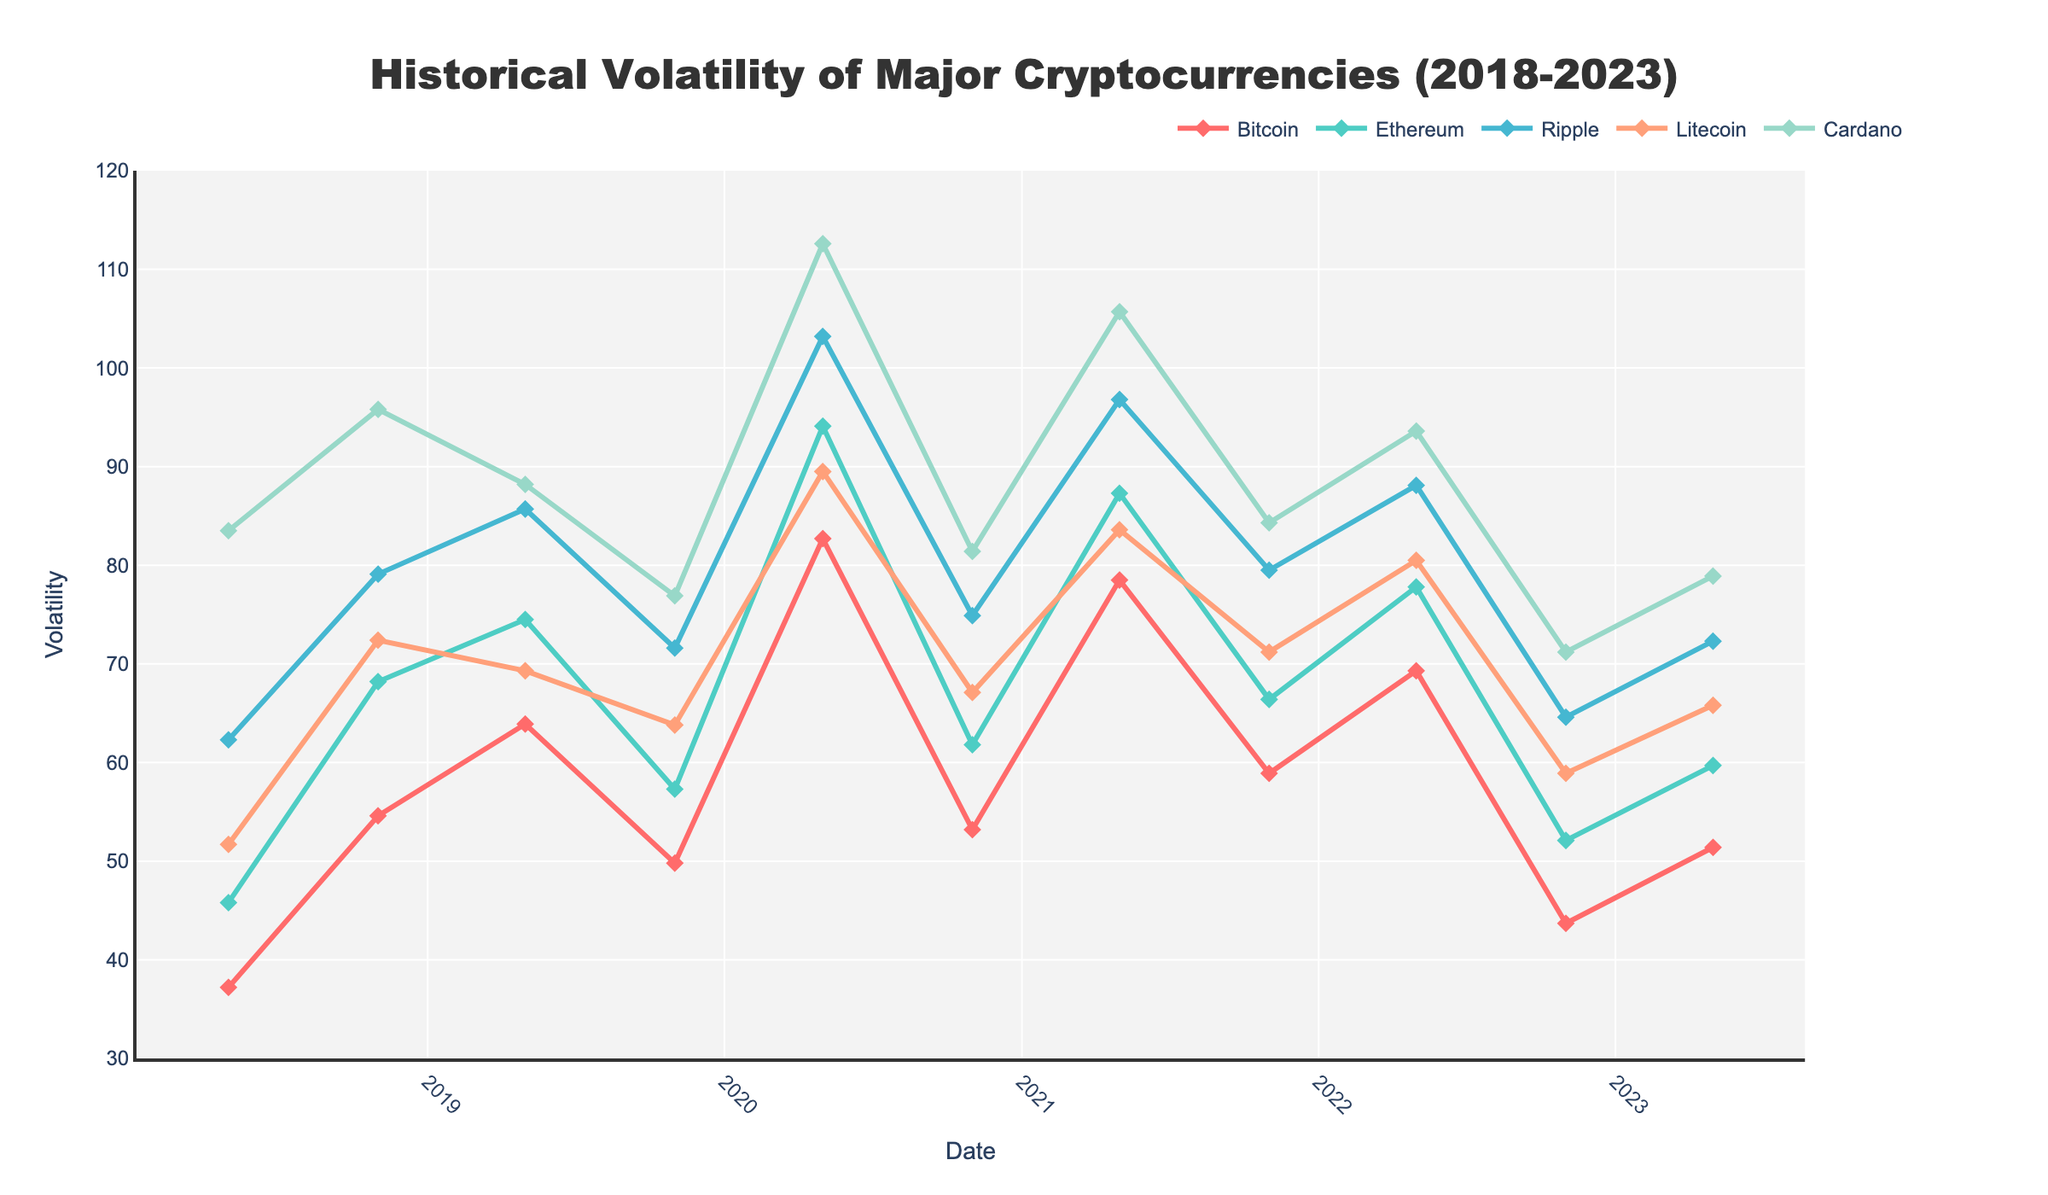Which cryptocurrency had the highest volatility in May 2020? Looking at the chart, find the highest point for May 2020. Cardano has the highest volatility among the cryptocurrencies listed.
Answer: Cardano How did Bitcoin's volatility change from November 2020 to May 2021? Locate Bitcoin's volatility values for November 2020 and May 2021. Bitcoin's volatility increased from 53.2 to 78.5.
Answer: It increased Which two cryptocurrencies had similar volatility in November 2022? Compare the volatility values of all cryptocurrencies for November 2022. Ripple and Litecoin had similar volatility values of 64.6 and 58.9, respectively.
Answer: Ripple and Litecoin What was the overall trend in Ethereum's volatility from 2018 to 2023? Observe Ethereum's volatility line from the start to the end of the period. Ethereum's volatility shows both increases and decreases but generally decreased over the period.
Answer: General decrease Between May 2021 and November 2021, which cryptocurrency experienced the largest decrease in volatility? Compare the drop in volatility for each cryptocurrency between these two dates. Bitcoin had the largest decrease from 78.5 to 58.9.
Answer: Bitcoin Which cryptocurrency had the least volatility in May 2021, and what was its value? Identify the lowest point among all cryptocurrencies in May 2021. Bitcoin had the least volatility value (78.5).
Answer: Bitcoin, 78.5 Compare the volatility of Ethereum and Ripple in May 2019. Which one was higher? Check their volatility values in May 2019 and compare. Ethereum had a volatility of 74.5, while Ripple had 85.7. Ripple's volatility was higher.
Answer: Ripple Analyze the volatility trend of Litecoin between 2020 and 2021. What pattern do you observe? Check Litecoin’s volatility from the start of 2020 to the end of 2021. Litecoin’s volatility increased in May 2020, decreased in November 2020, increased again in May 2021, and then decreased by November 2021.
Answer: Fluctuating pattern Calculate the average volatility for Cardano from 2018 to 2023. Add up Cardano's volatility values at each date and divide by the number of dates. (83.5 + 95.8 + 88.2 + 76.9 + 112.6 + 81.4 + 105.7 + 84.3 + 93.6 + 71.2 + 78.9) / 11 = 88.1
Answer: 88.1 